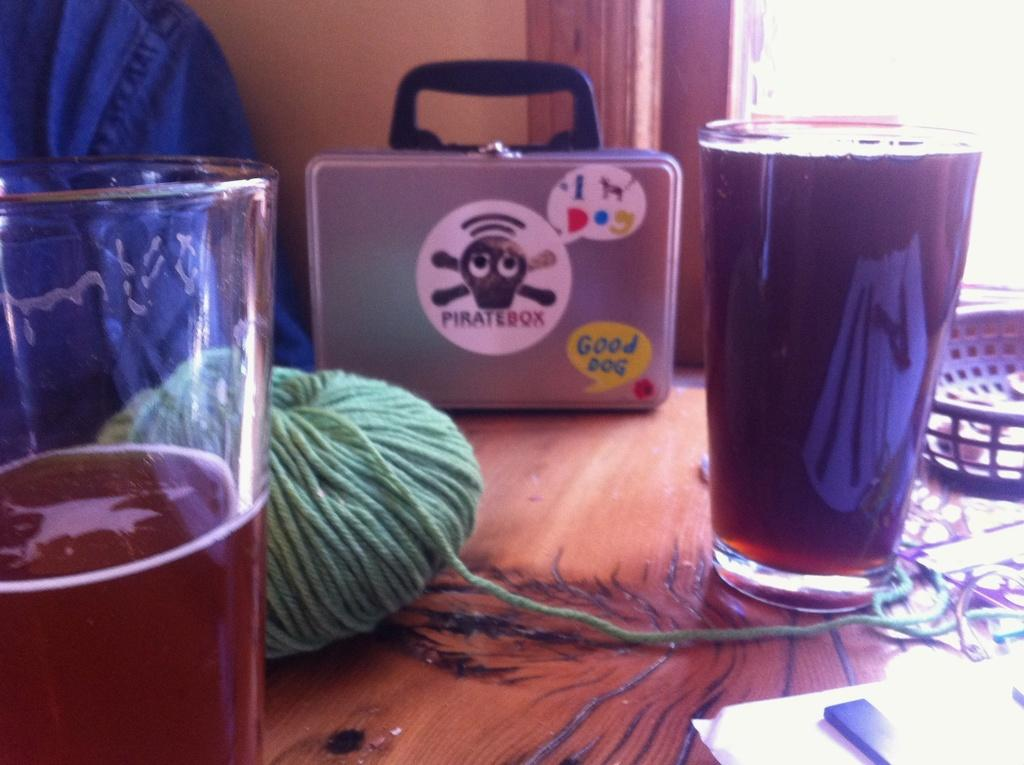<image>
Provide a brief description of the given image. A pirate box sitting on a wooden table behind two beer glasses. 